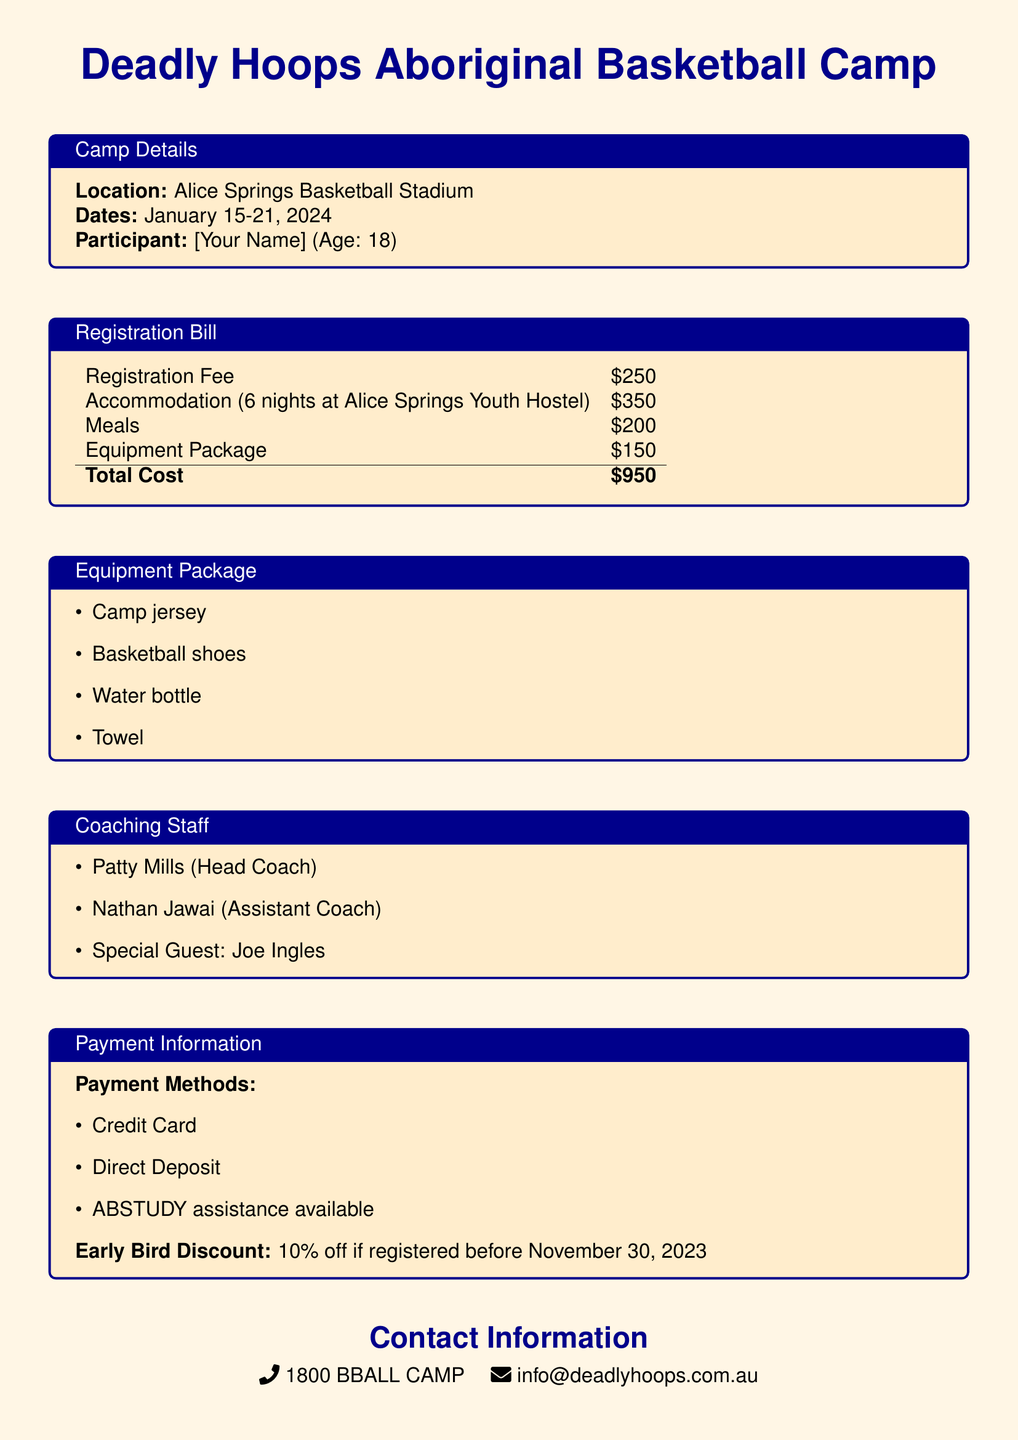What is the location of the camp? The camp is located at Alice Springs Basketball Stadium, which is specified in the camp details.
Answer: Alice Springs Basketball Stadium What are the dates of the camp? The camp dates are mentioned in the camp details, which state it runs from January 15-21, 2024.
Answer: January 15-21, 2024 How much is the registration fee? The registration fee is listed as a specific cost in the registration bill.
Answer: $250 What is the total cost of the camp? The total cost is calculated as the sum of all fees listed in the registration bill.
Answer: $950 Who is the head coach of the camp? The head coach's name is mentioned in the coaching staff section.
Answer: Patty Mills How many nights of accommodation are included? The document states that accommodation is for 6 nights at the specified hostel.
Answer: 6 nights What is included in the equipment package? The equipment package specifically lists items included, which can be found in that section.
Answer: Camp jersey, basketball shoes, water bottle, towel What is the early bird discount percentage? The early bird discount percentage is detailed in the payment information section.
Answer: 10% What payment methods are available? The payment information section lists the methods, which are essential for registration.
Answer: Credit Card, Direct Deposit, ABSTUDY assistance available 